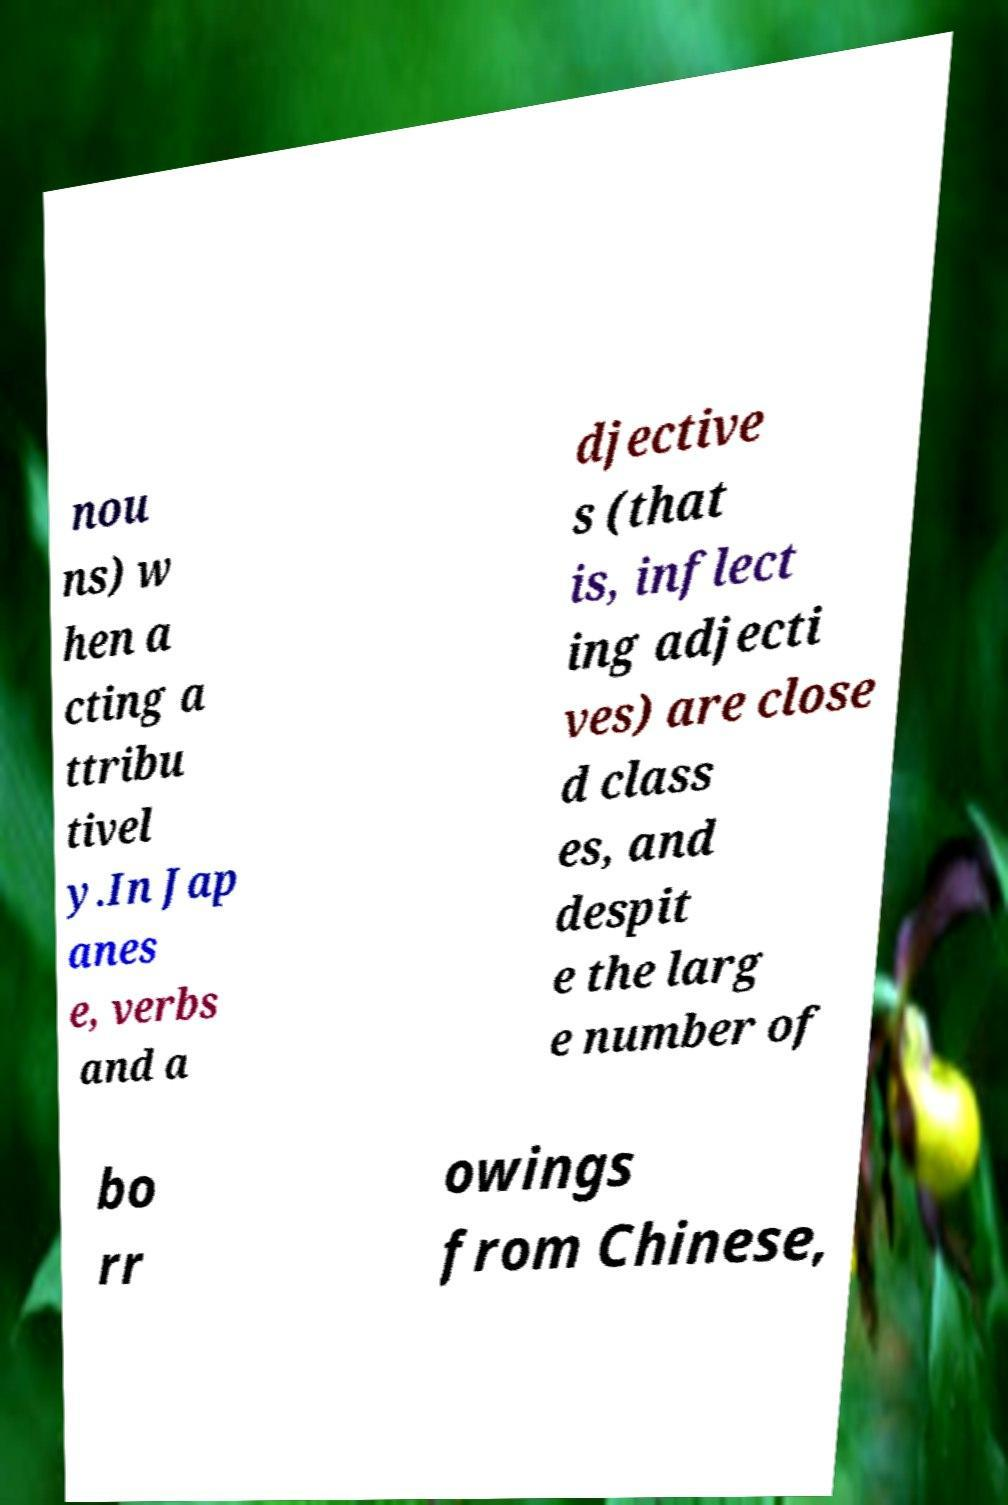Could you extract and type out the text from this image? nou ns) w hen a cting a ttribu tivel y.In Jap anes e, verbs and a djective s (that is, inflect ing adjecti ves) are close d class es, and despit e the larg e number of bo rr owings from Chinese, 